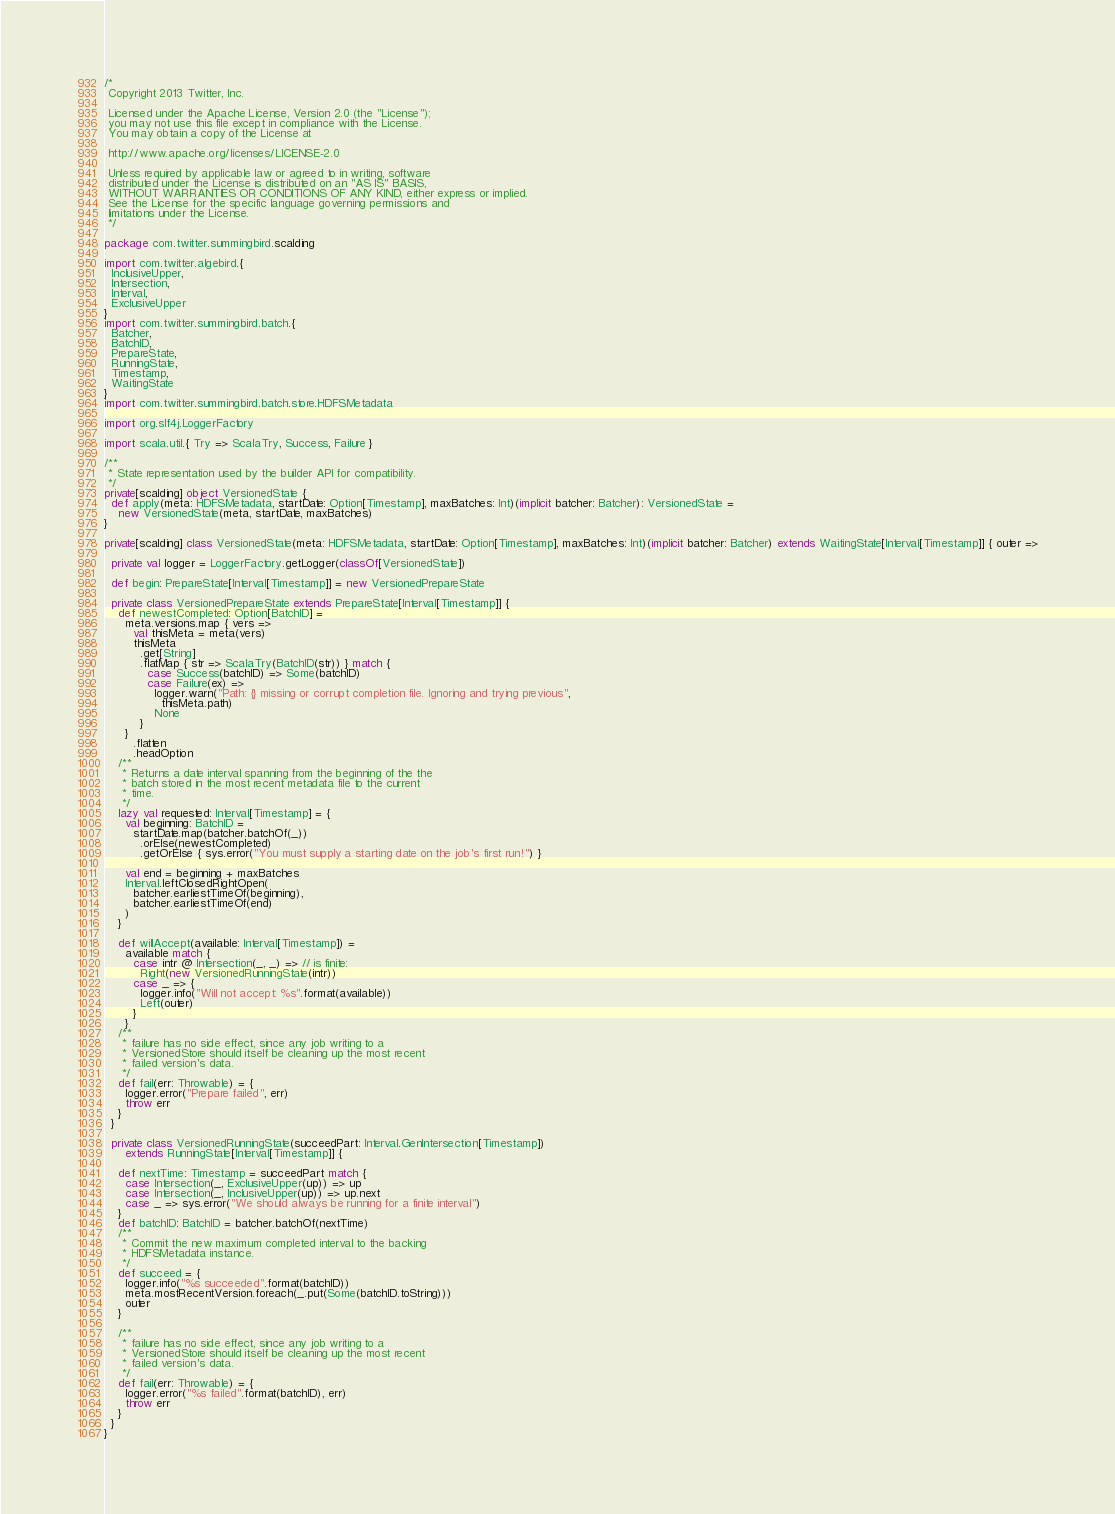Convert code to text. <code><loc_0><loc_0><loc_500><loc_500><_Scala_>/*
 Copyright 2013 Twitter, Inc.

 Licensed under the Apache License, Version 2.0 (the "License");
 you may not use this file except in compliance with the License.
 You may obtain a copy of the License at

 http://www.apache.org/licenses/LICENSE-2.0

 Unless required by applicable law or agreed to in writing, software
 distributed under the License is distributed on an "AS IS" BASIS,
 WITHOUT WARRANTIES OR CONDITIONS OF ANY KIND, either express or implied.
 See the License for the specific language governing permissions and
 limitations under the License.
 */

package com.twitter.summingbird.scalding

import com.twitter.algebird.{
  InclusiveUpper,
  Intersection,
  Interval,
  ExclusiveUpper
}
import com.twitter.summingbird.batch.{
  Batcher,
  BatchID,
  PrepareState,
  RunningState,
  Timestamp,
  WaitingState
}
import com.twitter.summingbird.batch.store.HDFSMetadata

import org.slf4j.LoggerFactory

import scala.util.{ Try => ScalaTry, Success, Failure }

/**
 * State representation used by the builder API for compatibility.
 */
private[scalding] object VersionedState {
  def apply(meta: HDFSMetadata, startDate: Option[Timestamp], maxBatches: Int)(implicit batcher: Batcher): VersionedState =
    new VersionedState(meta, startDate, maxBatches)
}

private[scalding] class VersionedState(meta: HDFSMetadata, startDate: Option[Timestamp], maxBatches: Int)(implicit batcher: Batcher) extends WaitingState[Interval[Timestamp]] { outer =>

  private val logger = LoggerFactory.getLogger(classOf[VersionedState])

  def begin: PrepareState[Interval[Timestamp]] = new VersionedPrepareState

  private class VersionedPrepareState extends PrepareState[Interval[Timestamp]] {
    def newestCompleted: Option[BatchID] =
      meta.versions.map { vers =>
        val thisMeta = meta(vers)
        thisMeta
          .get[String]
          .flatMap { str => ScalaTry(BatchID(str)) } match {
            case Success(batchID) => Some(batchID)
            case Failure(ex) =>
              logger.warn("Path: {} missing or corrupt completion file. Ignoring and trying previous",
                thisMeta.path)
              None
          }
      }
        .flatten
        .headOption
    /**
     * Returns a date interval spanning from the beginning of the the
     * batch stored in the most recent metadata file to the current
     * time.
     */
    lazy val requested: Interval[Timestamp] = {
      val beginning: BatchID =
        startDate.map(batcher.batchOf(_))
          .orElse(newestCompleted)
          .getOrElse { sys.error("You must supply a starting date on the job's first run!") }

      val end = beginning + maxBatches
      Interval.leftClosedRightOpen(
        batcher.earliestTimeOf(beginning),
        batcher.earliestTimeOf(end)
      )
    }

    def willAccept(available: Interval[Timestamp]) =
      available match {
        case intr @ Intersection(_, _) => // is finite:
          Right(new VersionedRunningState(intr))
        case _ => {
          logger.info("Will not accept: %s".format(available))
          Left(outer)
        }
      }
    /**
     * failure has no side effect, since any job writing to a
     * VersionedStore should itself be cleaning up the most recent
     * failed version's data.
     */
    def fail(err: Throwable) = {
      logger.error("Prepare failed", err)
      throw err
    }
  }

  private class VersionedRunningState(succeedPart: Interval.GenIntersection[Timestamp])
      extends RunningState[Interval[Timestamp]] {

    def nextTime: Timestamp = succeedPart match {
      case Intersection(_, ExclusiveUpper(up)) => up
      case Intersection(_, InclusiveUpper(up)) => up.next
      case _ => sys.error("We should always be running for a finite interval")
    }
    def batchID: BatchID = batcher.batchOf(nextTime)
    /**
     * Commit the new maximum completed interval to the backing
     * HDFSMetadata instance.
     */
    def succeed = {
      logger.info("%s succeeded".format(batchID))
      meta.mostRecentVersion.foreach(_.put(Some(batchID.toString)))
      outer
    }

    /**
     * failure has no side effect, since any job writing to a
     * VersionedStore should itself be cleaning up the most recent
     * failed version's data.
     */
    def fail(err: Throwable) = {
      logger.error("%s failed".format(batchID), err)
      throw err
    }
  }
}
</code> 